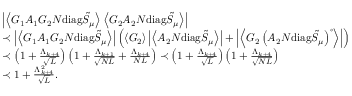<formula> <loc_0><loc_0><loc_500><loc_500>\begin{array} { r l } & { \left | \left \langle { G _ { 1 } A _ { 1 } G _ { 2 } N d i a g \tilde { S } _ { \mu } } \right \rangle \left \langle { G _ { 2 } A _ { 2 } N d i a g \tilde { S } _ { \mu } } \right \rangle \right | } \\ & { \prec \left | \left \langle { G _ { 1 } A _ { 1 } G _ { 2 } N d i a g \tilde { S } _ { \mu } } \right \rangle \right | \left ( \left \langle { G _ { 2 } } \right \rangle \left | \left \langle { A _ { 2 } N d i a g \tilde { S } _ { \mu } } \right \rangle \right | + \left | \left \langle { G _ { 2 } \left ( A _ { 2 } N d i a g \tilde { S } _ { \mu } \right ) ^ { \circ } } \right \rangle \right | \right ) } \\ & { \prec \left ( 1 + \frac { \Lambda _ { k + 4 } } { \sqrt { L } } \right ) \left ( 1 + \frac { \Lambda _ { k + 1 } } { \sqrt { N L } } + \frac { \Lambda _ { k + 4 } } { N L } \right ) \prec \left ( 1 + \frac { \Lambda _ { k + 4 } } { \sqrt { L } } \right ) \left ( 1 + \frac { \Lambda _ { k + 4 } } { \sqrt { N L } } \right ) } \\ & { \prec 1 + \frac { \Lambda _ { k + 4 } ^ { 2 } } { \sqrt { L } } . } \end{array}</formula> 